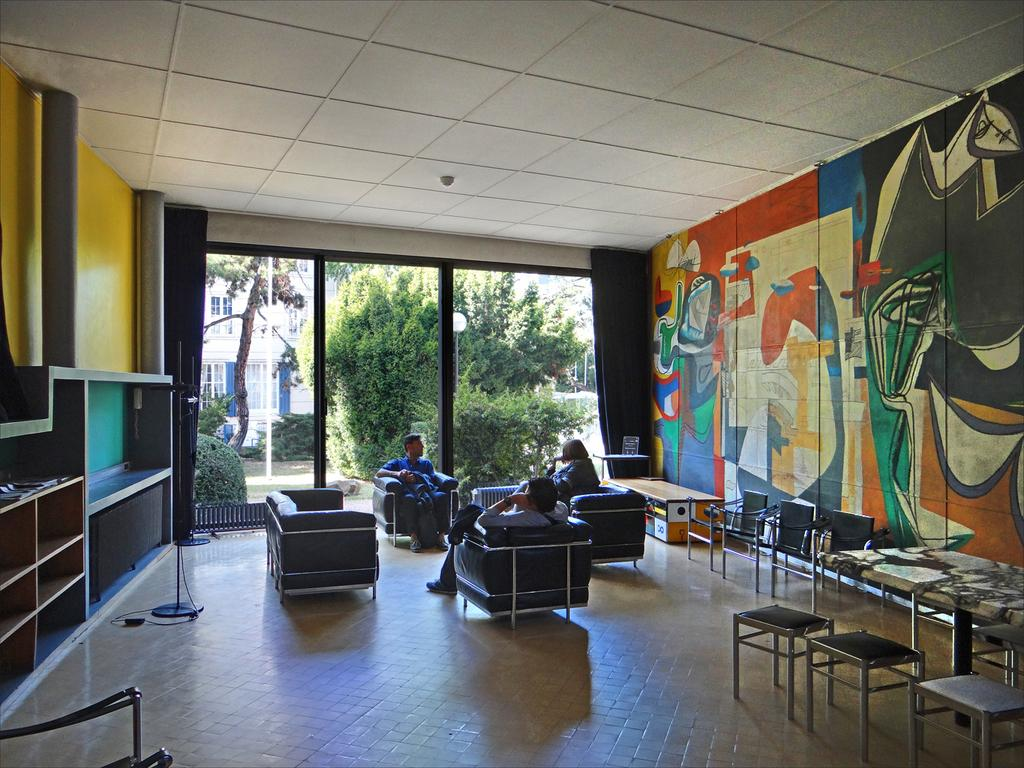How many people are in the image? There are three persons in the image. What are the persons doing in the image? The persons are sitting on a sofa. What can be seen on the walls in the image? There are painted walls on either side of the sofa. What is visible in the background of the image? There are trees and buildings in the background of the image. What are the hobbies of the persons in the image? The provided facts do not give information about the hobbies of the persons in the image. --- Facts: 1. There is a car in the image. 2. The car is red. 3. The car has four wheels. 4. There are people in the car. 5. The car is parked on the street. Absurd Topics: dance, ocean, bird Conversation: What is the main subject of the image? The main subject of the image is a car. What color is the car? The car is red. How many wheels does the car have? The car has four wheels. Are there any passengers in the car? Yes, there are people in the car. Where is the car located in the image? The car is parked on the street. Reasoning: Let's think step by step in order to produce the conversation. We start by identifying the main subject of the image, which is the car. Then, we describe the car's color and the number of wheels it has. Next, we mention the presence of passengers in the car. Finally, we describe the car's location, which is parked on the street. Absurd Question/Answer: Can you see any birds flying over the ocean in the image? There is no ocean or birds present in the image; it features a red car parked on the street with people inside. 